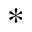<formula> <loc_0><loc_0><loc_500><loc_500>*</formula> 